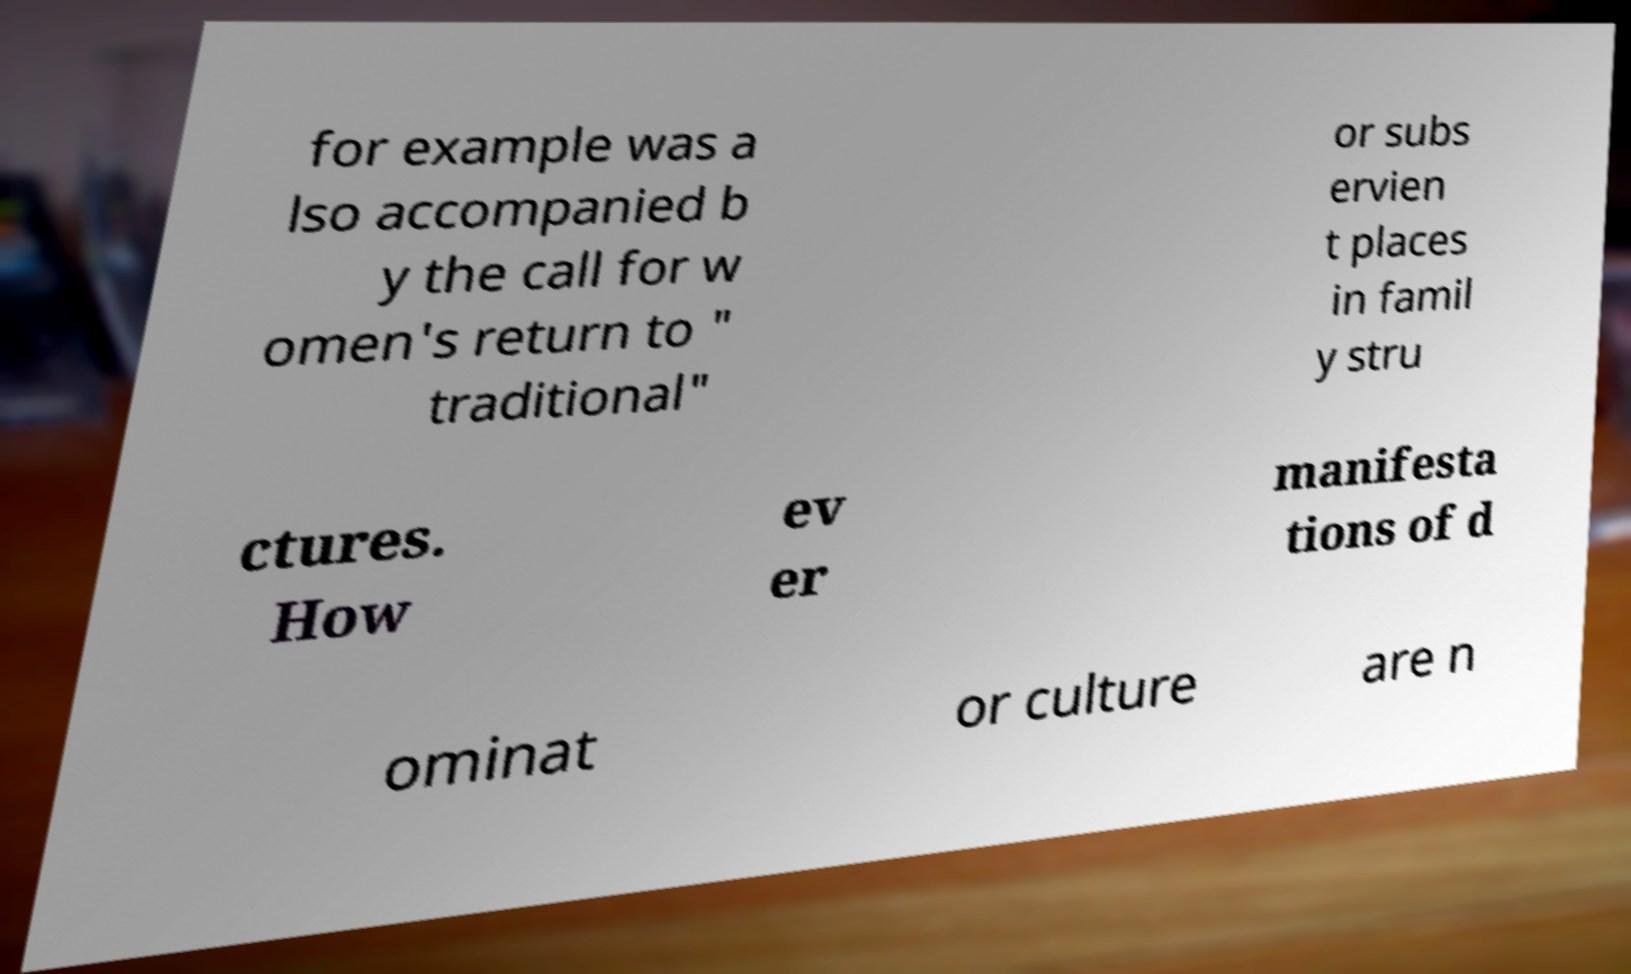Can you accurately transcribe the text from the provided image for me? for example was a lso accompanied b y the call for w omen's return to " traditional" or subs ervien t places in famil y stru ctures. How ev er manifesta tions of d ominat or culture are n 